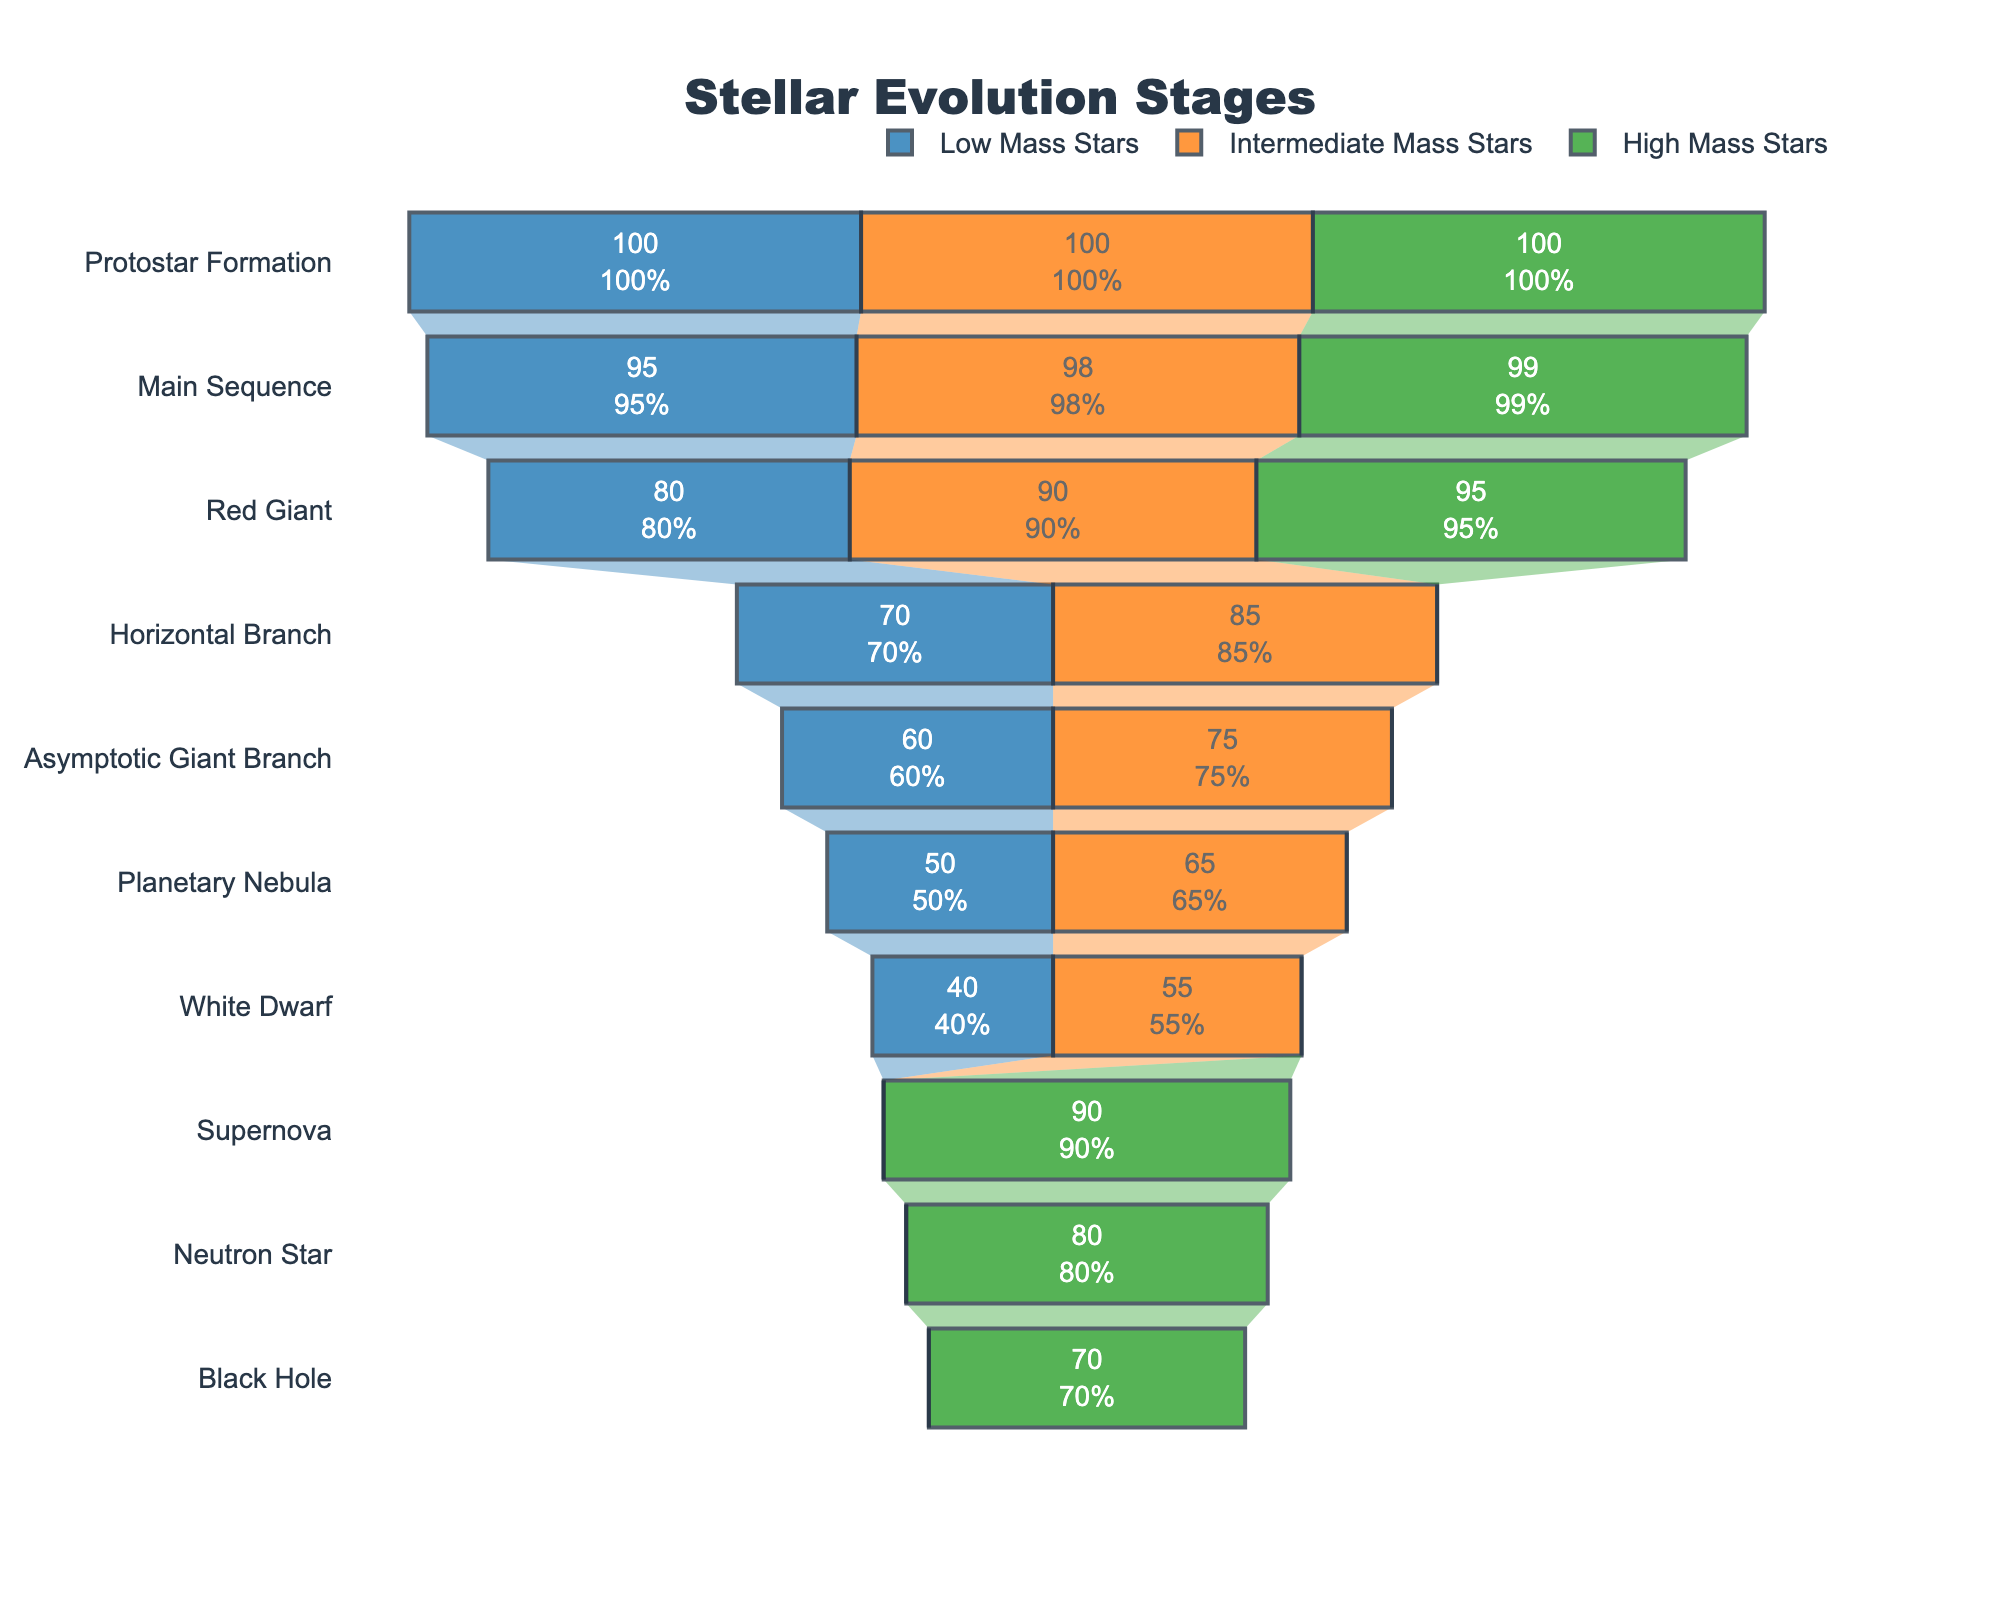what is the title of the figure? The title is prominently displayed at the top of the chart. By looking at it, we see the text "Stellar Evolution Stages".
Answer: Stellar Evolution Stages How many stars remain on the Main Sequence stage for Low Mass Stars? In the figure, we can see that the Main Sequence stage for Low Mass Stars shows '95' within the funnel.
Answer: 95 Which star category has the stage "Supernova"? By examining the names associated with the Supernova stage in the plot, we see that it only applies to High Mass Stars.
Answer: High Mass Stars How many stages do Intermediate Mass Stars go through from Protostar Formation to White Dwarf? Counting the stages from Protostar Formation to White Dwarf for Intermediate Mass Stars involves going through the stages: Protostar Formation, Main Sequence, Red Giant, Horizontal Branch, Asymptotic Giant Branch, Planetary Nebula, and White Dwarf. That totals to seven stages.
Answer: 7 stages What is the percentage of High Mass Stars evolving into Black Holes relative to the initial Protostar Formation? The Black Hole stage for High Mass Stars shows '70' remaining. From the initial Protostar Formation stage with '100', the percentage is (70/100)*100%.
Answer: 70% What is the aggregate final stage count of stars ending as White Dwarfs for both Low and Intermediate Mass Stars? Adding the value for White Dwarfs in Low Mass Stars (40) and Intermediate Mass Stars (55), we get 40 + 55 = 95.
Answer: 95 Which stage has the most remaining stars for all categories combined, ignoring stages specific to one type of star? We need to find the stage, summed across all star types, that has the highest count. Protostar Formation has 100 (Low) + 100 (Intermediate) + 100 (High) = 300, which is the highest.
Answer: Protostar Formation On which stage does the number of Intermediate Mass Stars significantly drop compared to the previous stage? Comparing counts in consecutive stages for Intermediate Mass Stars, the largest drop appears between the Main Sequence (98) and Red Giant (90) stages, which is a reduction of 8 stars.
Answer: Red Giant Between Low Mass and High Mass Stars, which category has the higher count of stars remaining in the Red Giant stage? By looking at the funnel chart at the Red Giant stage, we see Low Mass Stars have '80' remaining and High Mass Stars have '95' remaining. Thus, High Mass Stars have more.
Answer: High Mass Stars 